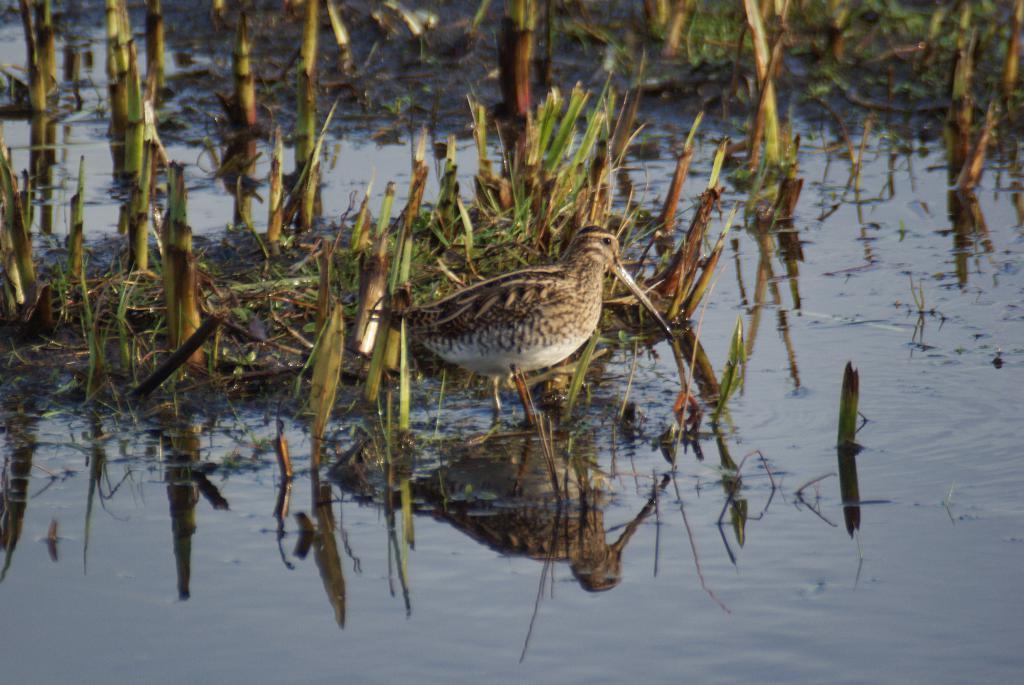Can you describe this image briefly? In this image in the center there is a bird standing and in the background there are plants and in the front there is water. 